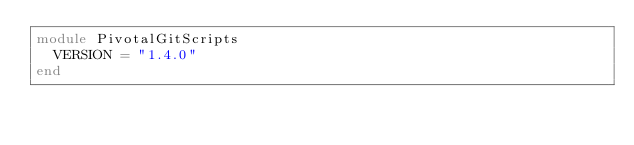Convert code to text. <code><loc_0><loc_0><loc_500><loc_500><_Ruby_>module PivotalGitScripts
  VERSION = "1.4.0"
end
</code> 